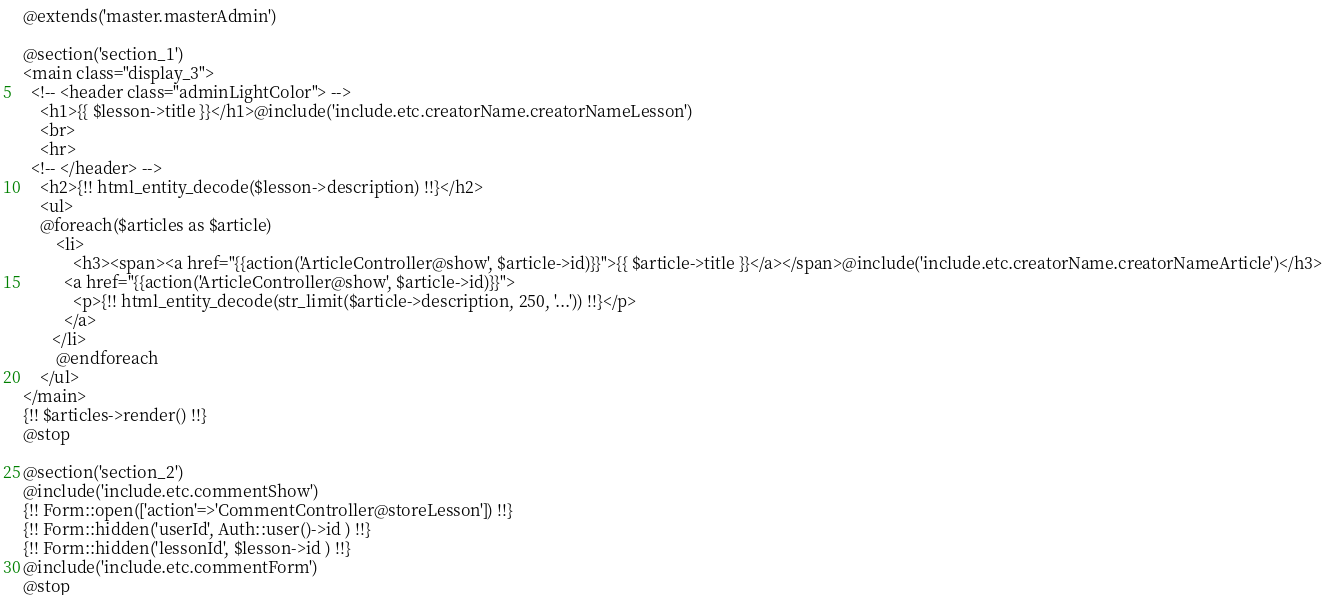Convert code to text. <code><loc_0><loc_0><loc_500><loc_500><_PHP_>@extends('master.masterAdmin')

@section('section_1')
<main class="display_3">
  <!-- <header class="adminLightColor"> -->
    <h1>{{ $lesson->title }}</h1>@include('include.etc.creatorName.creatorNameLesson')
    <br>
    <hr>
  <!-- </header> -->
    <h2>{!! html_entity_decode($lesson->description) !!}</h2>
  	<ul>
    @foreach($articles as $article)
    	<li>
    		<h3><span><a href="{{action('ArticleController@show', $article->id)}}">{{ $article->title }}</a></span>@include('include.etc.creatorName.creatorNameArticle')</h3>
          <a href="{{action('ArticleController@show', $article->id)}}">
            <p>{!! html_entity_decode(str_limit($article->description, 250, '...')) !!}</p>  
          </a>
       </li>
    	@endforeach
    </ul>
</main>
{!! $articles->render() !!}
@stop

@section('section_2')
@include('include.etc.commentShow')
{!! Form::open(['action'=>'CommentController@storeLesson']) !!}
{!! Form::hidden('userId', Auth::user()->id ) !!}
{!! Form::hidden('lessonId', $lesson->id ) !!}
@include('include.etc.commentForm')
@stop</code> 